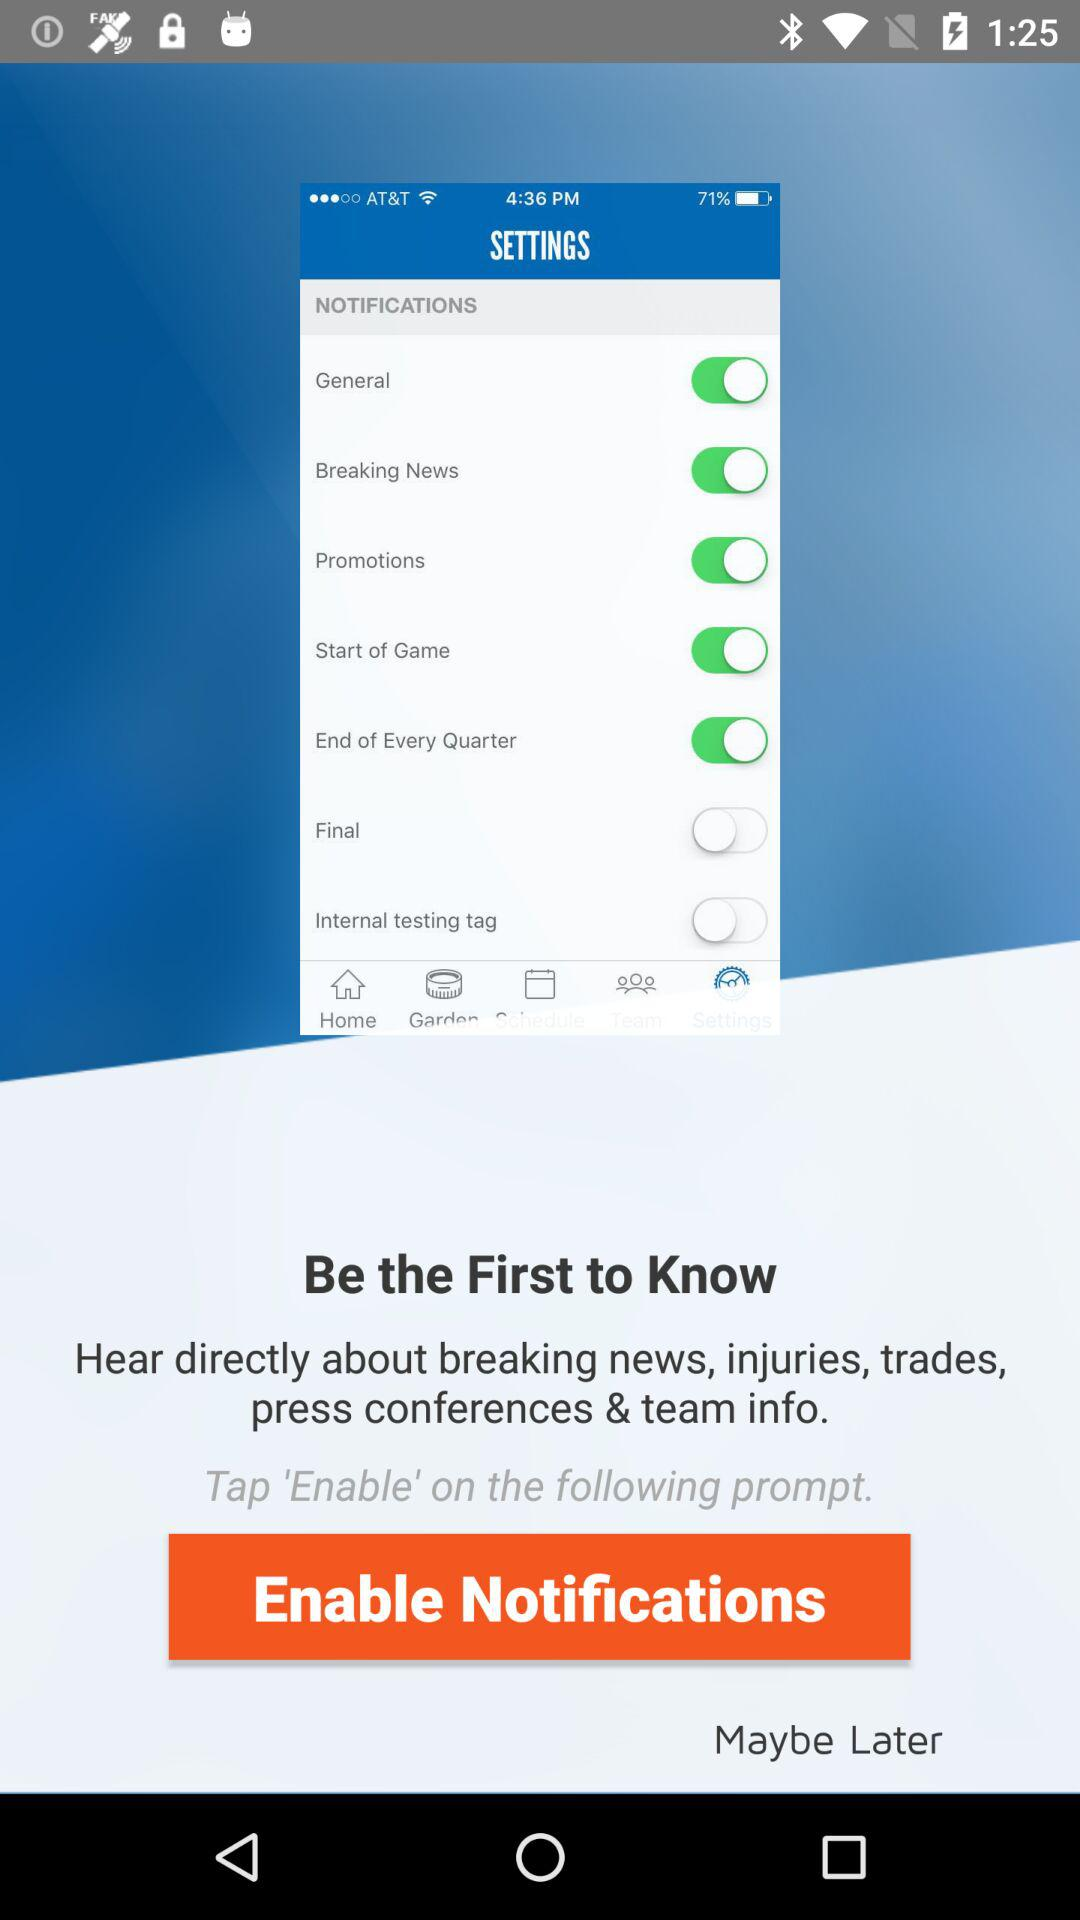Which notifications are enabled? The enabled notifications are "General", "Breaking News", "Promotions", "Start of Game", and "End of Every Quarter". 